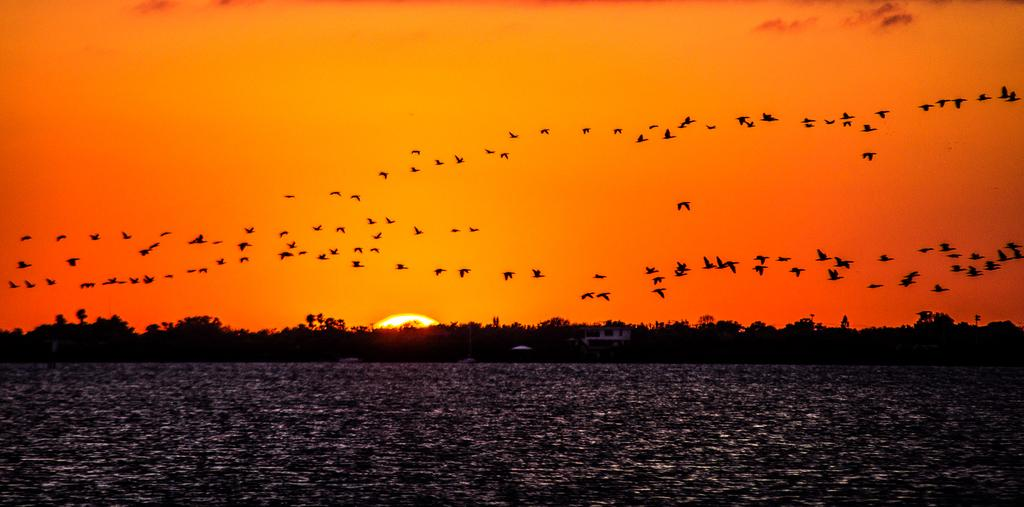What is the main element present in the image? There is water in the image. What type of structure can be seen in the image? There is a house in the image. What type of vegetation is present in the image? There are trees in the image. What type of animals are visible in the image? Birds are flying in the sky in the image. What celestial body is visible in the background of the image? The sun is visible in the sky in the background of the image. What type of cork can be seen floating on the water in the image? There is no cork present in the image; it only features water, a house, trees, birds, and the sun. 